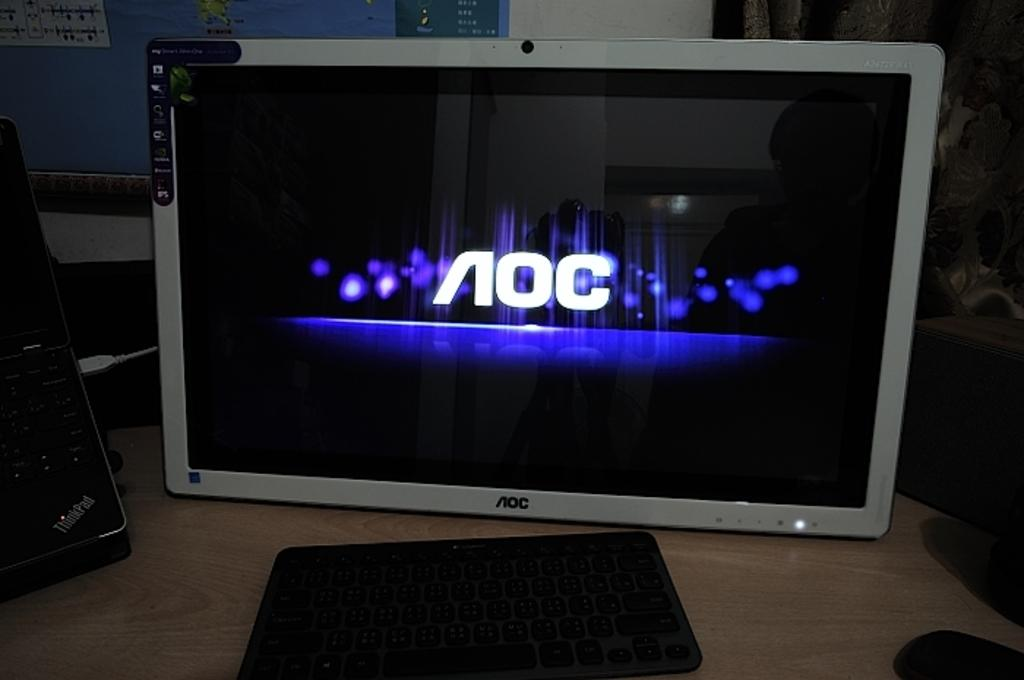<image>
Create a compact narrative representing the image presented. An AOC branded computer monitor is displaying the AOC logo on the screen. 